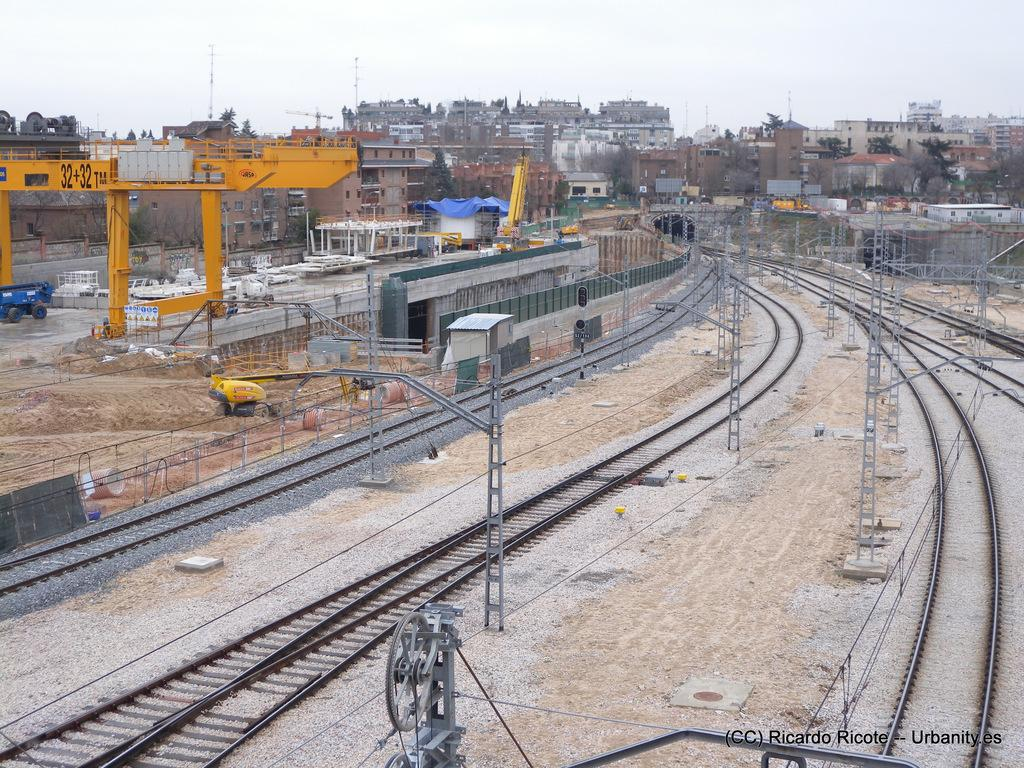<image>
Describe the image concisely. Train tracks with a yellow platform that says 32 on it. 